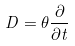<formula> <loc_0><loc_0><loc_500><loc_500>D = \theta \frac { \partial } { \partial t }</formula> 